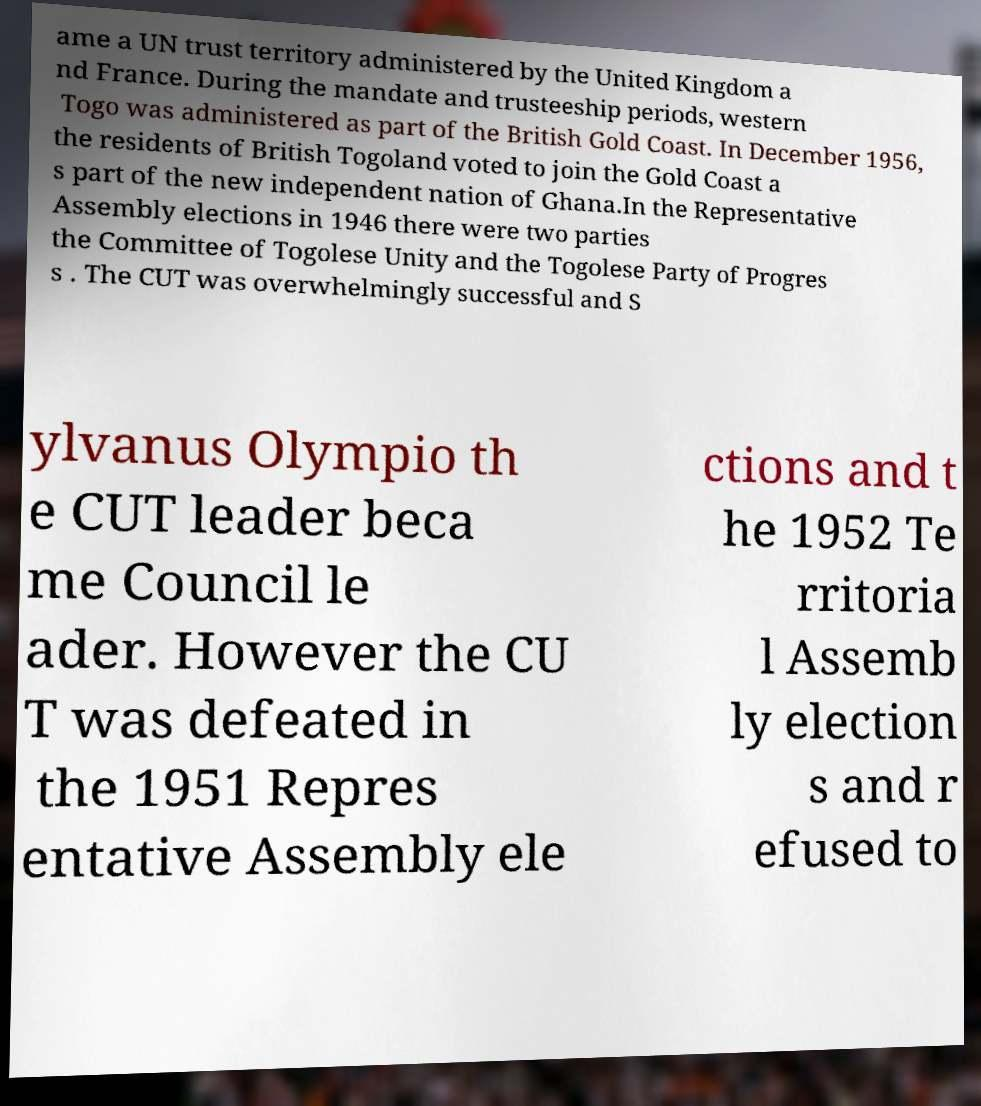There's text embedded in this image that I need extracted. Can you transcribe it verbatim? ame a UN trust territory administered by the United Kingdom a nd France. During the mandate and trusteeship periods, western Togo was administered as part of the British Gold Coast. In December 1956, the residents of British Togoland voted to join the Gold Coast a s part of the new independent nation of Ghana.In the Representative Assembly elections in 1946 there were two parties the Committee of Togolese Unity and the Togolese Party of Progres s . The CUT was overwhelmingly successful and S ylvanus Olympio th e CUT leader beca me Council le ader. However the CU T was defeated in the 1951 Repres entative Assembly ele ctions and t he 1952 Te rritoria l Assemb ly election s and r efused to 